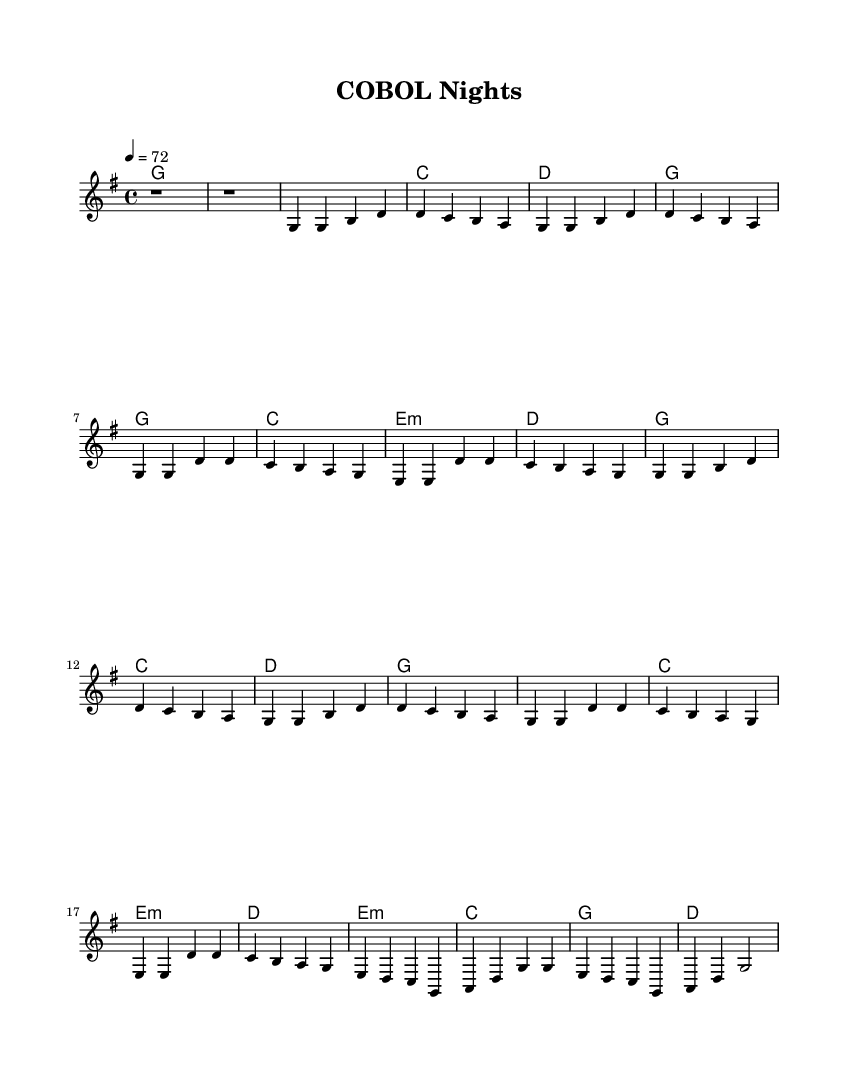What is the key signature of this music? The key signature is G major, which has one sharp (F#). This can be determined by looking at the key signature indicated at the beginning of the staff.
Answer: G major What is the time signature of this music? The time signature is 4/4, which is shown at the start of the sheet music. This indicates that there are four beats in each measure and a quarter note gets one beat.
Answer: 4/4 What is the tempo marking for this music? The tempo marking is 72 beats per minute, indicated by "4 = 72." This tells musicians how fast the piece should be played.
Answer: 72 How many measures are there in the chorus? The chorus consists of four measures as reflected in the repeated section after both verses. The line structure shows it total four measures before moving on.
Answer: 4 Which chords are used in the bridge section? The bridge consists of three chords: E minor, C major, and G major, which are represented in the harmonies section and outline the harmonic progression for this part of the song.
Answer: E minor, C, G What is the melody's rhythm pattern in the first verse? The rhythm pattern of the first verse consists mainly of quarter notes, each lasting for one beat. This is clear from the notes in the measure.
Answer: Quarter notes How does the structure of the song reflect typical country rock elements? The song has a simple verse-chorus structure, which is common in country rock. The use of nostalgic themes about programming also aligns with storytelling found in country rock lyrics.
Answer: Verse-Chorus structure 